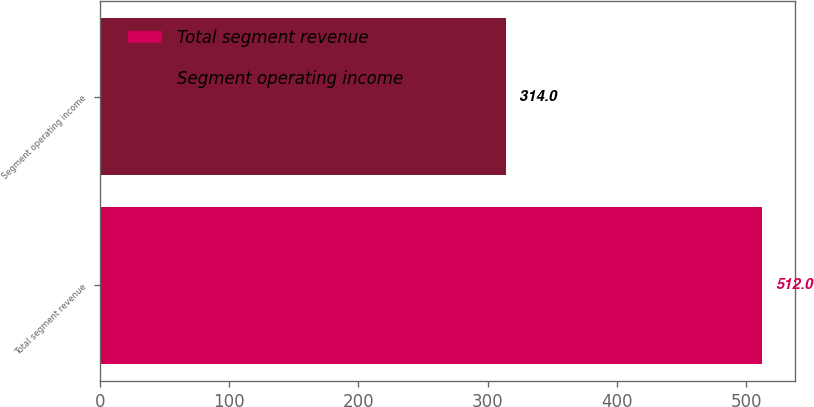Convert chart to OTSL. <chart><loc_0><loc_0><loc_500><loc_500><bar_chart><fcel>Total segment revenue<fcel>Segment operating income<nl><fcel>512<fcel>314<nl></chart> 